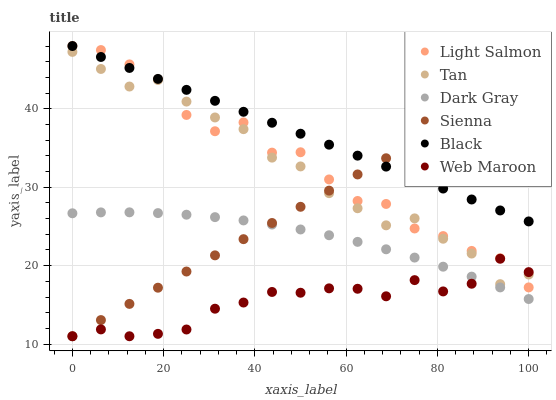Does Web Maroon have the minimum area under the curve?
Answer yes or no. Yes. Does Black have the maximum area under the curve?
Answer yes or no. Yes. Does Light Salmon have the minimum area under the curve?
Answer yes or no. No. Does Light Salmon have the maximum area under the curve?
Answer yes or no. No. Is Sienna the smoothest?
Answer yes or no. Yes. Is Light Salmon the roughest?
Answer yes or no. Yes. Is Web Maroon the smoothest?
Answer yes or no. No. Is Web Maroon the roughest?
Answer yes or no. No. Does Sienna have the lowest value?
Answer yes or no. Yes. Does Light Salmon have the lowest value?
Answer yes or no. No. Does Black have the highest value?
Answer yes or no. Yes. Does Web Maroon have the highest value?
Answer yes or no. No. Is Web Maroon less than Black?
Answer yes or no. Yes. Is Black greater than Dark Gray?
Answer yes or no. Yes. Does Dark Gray intersect Web Maroon?
Answer yes or no. Yes. Is Dark Gray less than Web Maroon?
Answer yes or no. No. Is Dark Gray greater than Web Maroon?
Answer yes or no. No. Does Web Maroon intersect Black?
Answer yes or no. No. 